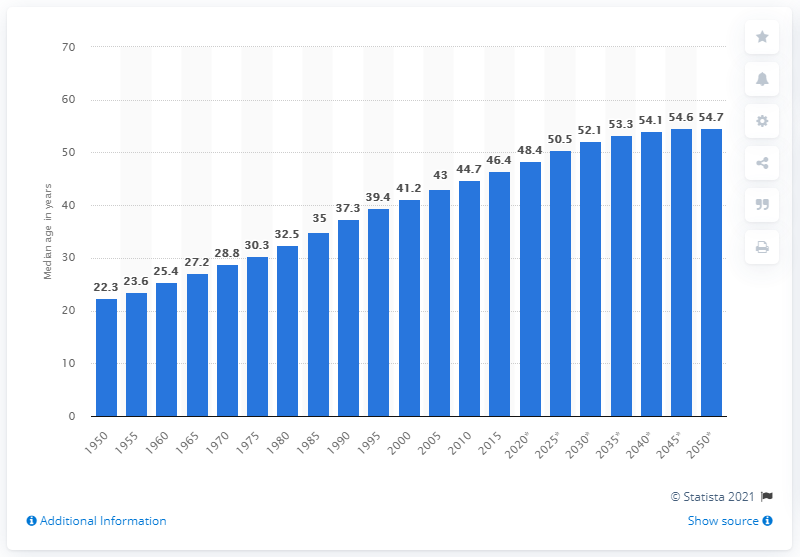Mention a couple of crucial points in this snapshot. The median age of the population in Japan has been increasing since 1950. 